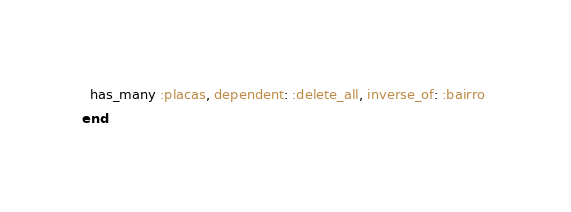<code> <loc_0><loc_0><loc_500><loc_500><_Ruby_>
  has_many :placas, dependent: :delete_all, inverse_of: :bairro 
end
</code> 